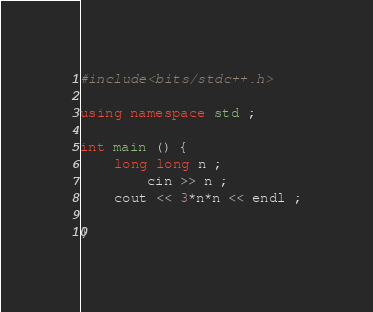<code> <loc_0><loc_0><loc_500><loc_500><_C++_>#include<bits/stdc++.h>

using namespace std ;

int main () {
    long long n ;
        cin >> n ;
    cout << 3*n*n << endl ;

}
</code> 